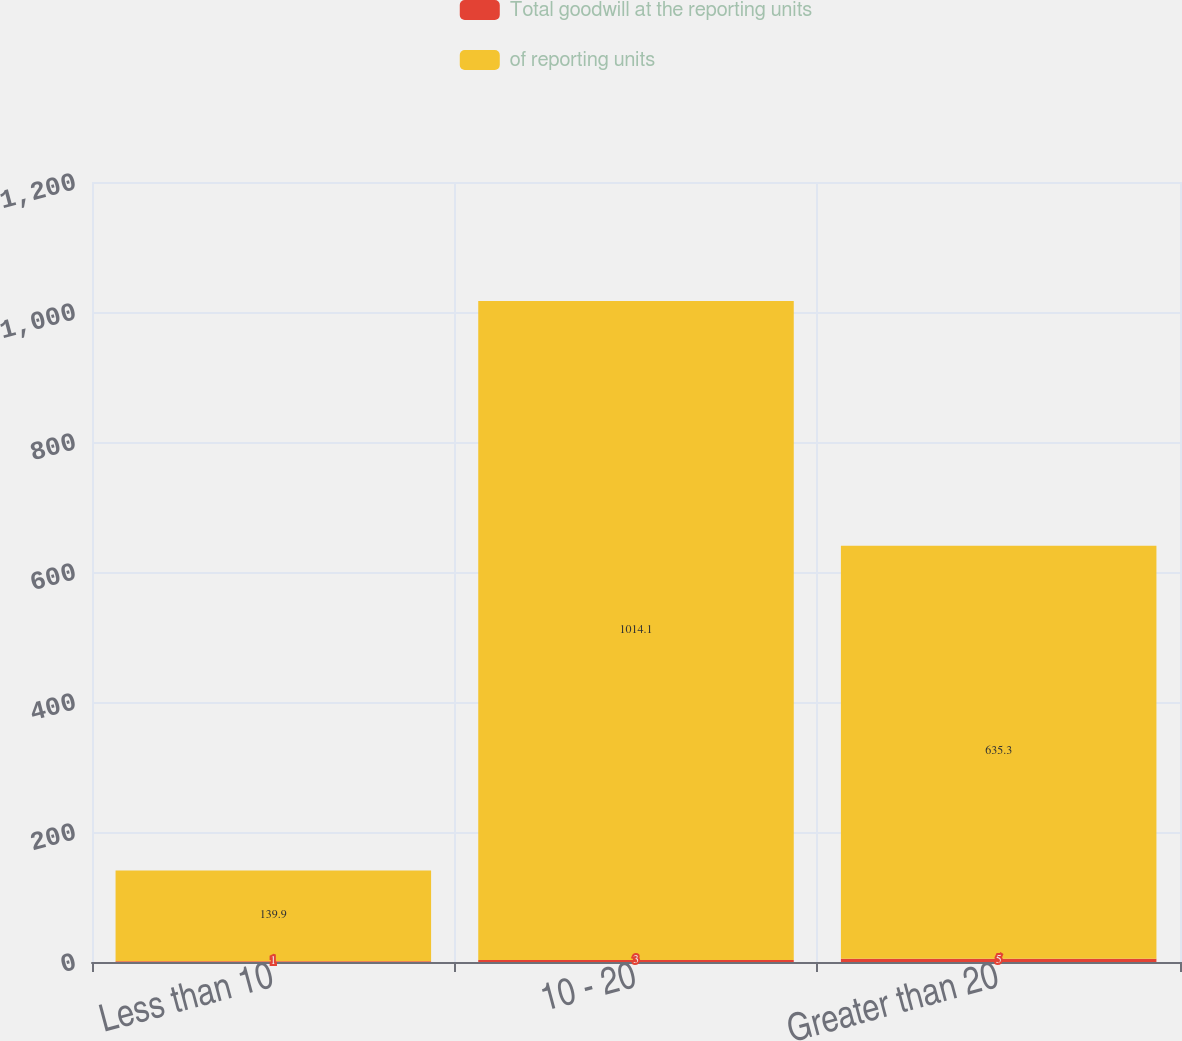Convert chart. <chart><loc_0><loc_0><loc_500><loc_500><stacked_bar_chart><ecel><fcel>Less than 10<fcel>10 - 20<fcel>Greater than 20<nl><fcel>Total goodwill at the reporting units<fcel>1<fcel>3<fcel>5<nl><fcel>of reporting units<fcel>139.9<fcel>1014.1<fcel>635.3<nl></chart> 